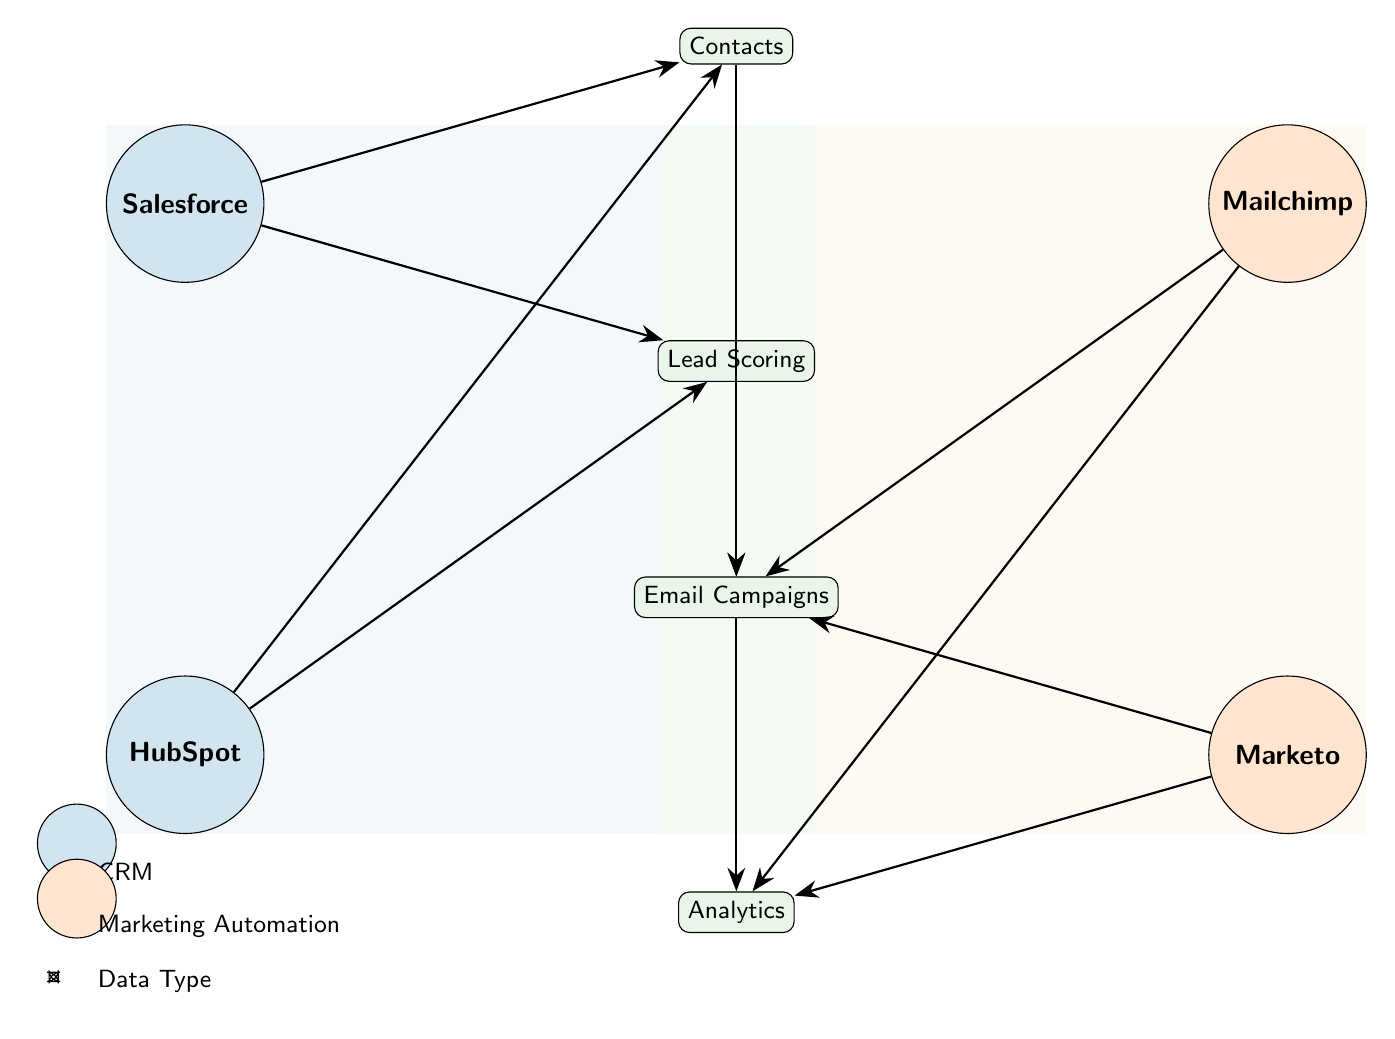What are the two CRM systems represented in the diagram? The diagram includes Salesforce and HubSpot as the two CRM systems, which can be identified as groups labeled "CRM" in the diagram.
Answer: Salesforce, HubSpot How many nodes are classified as Data Types? There are four nodes categorized as Data Types, which include Contacts, Lead Scoring, Email Campaigns, and Analytics. This can be determined by counting the nodes labeled under the "Data Type" group.
Answer: 4 What type of data is connected to both Salesforce and HubSpot? Both Salesforce and HubSpot are connected to Contacts and Lead Scoring, as indicated by the connections in the diagram. Both CRM systems have links going to these data type nodes.
Answer: Contacts, Lead Scoring Which Marketing Automation platforms are linked to Email Campaigns? Mailchimp and Marketo are both connected to Email Campaigns as shown by the edges leading to this data type from both marketing platforms in the diagram.
Answer: Mailchimp, Marketo How many connections are there from the Email Campaigns node to other nodes? The Email Campaigns node in the diagram has two outgoing connections: one to Analytics and one to the data types Contacts and Lead Scoring. Thus, it is connected to two other nodes beyond itself.
Answer: 2 Which data type receives input from both CRM systems for lead scoring? The data type for Lead Scoring receives input from both Salesforce and HubSpot, as indicated by the edges connecting both CRM nodes to the Lead Scoring data type node.
Answer: Lead Scoring What is the flow direction of the connections originating from Mailchimp? The flow direction of Mailchimp's connections is towards Email Campaigns and Analytics, indicating that Mailchimp sends data to these two data types in the diagram.
Answer: Towards Email Campaigns and Analytics Which data type acts as a hub for interactions between the CRM and Marketing Automation platforms? Email Campaigns serves as a hub since it connects to multiple nodes, receiving input from both the Contacts and Lead Scoring data type nodes as well as linking to both Marketing Automation platforms, Mailchimp and Marketo.
Answer: Email Campaigns 